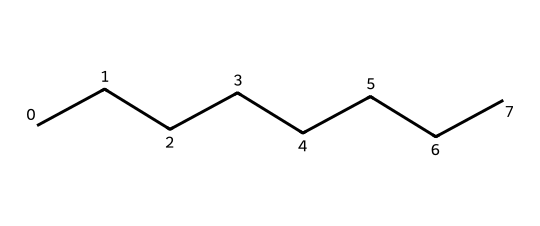What is the molecular formula of octane? The structural formula, represented by the SMILES CCCCCCCC, indicates that there are 8 carbon atoms and 18 hydrogen atoms in octane, leading to the molecular formula C8H18.
Answer: C8H18 How many carbon atoms are in octane? The SMILES representation shows a linear chain of 8 carbon atoms, as indicated by the eight "C" symbols.
Answer: 8 How many hydrogen atoms are in octane? Each carbon in octane typically forms four bonds. In this linear structure, there are terminal carbon atoms that are bonded to three hydrogens, while the internal carbons are bonded to two hydrogens, totaling 18 hydrogen atoms overall.
Answer: 18 What type of hydrocarbon is octane? Octane is determined to be an alkane because it consists of only carbon and hydrogen and contains single bonds between all of the carbon atoms as evidenced by the linear structure.
Answer: alkane Is octane a saturated hydrocarbon? Since octane contains all single bonds between carbon atoms, it is fully saturated with hydrogen, meaning it cannot add more hydrogen atoms. This confirms that octane is indeed a saturated hydrocarbon.
Answer: yes What is the significance of octane in fuel standards? Octane is crucial in fuel quality as it refers to the octane rating, which measures a fuel's ability to resist knocking during combustion, affecting engine performance.
Answer: fuel quality What is the boiling point range for octane? Octane has a boiling point of approximately 125-126 degrees Celsius, which can be identified from its structural formula and physical properties associated with hydrocarbons of its type.
Answer: 125-126 degrees Celsius 